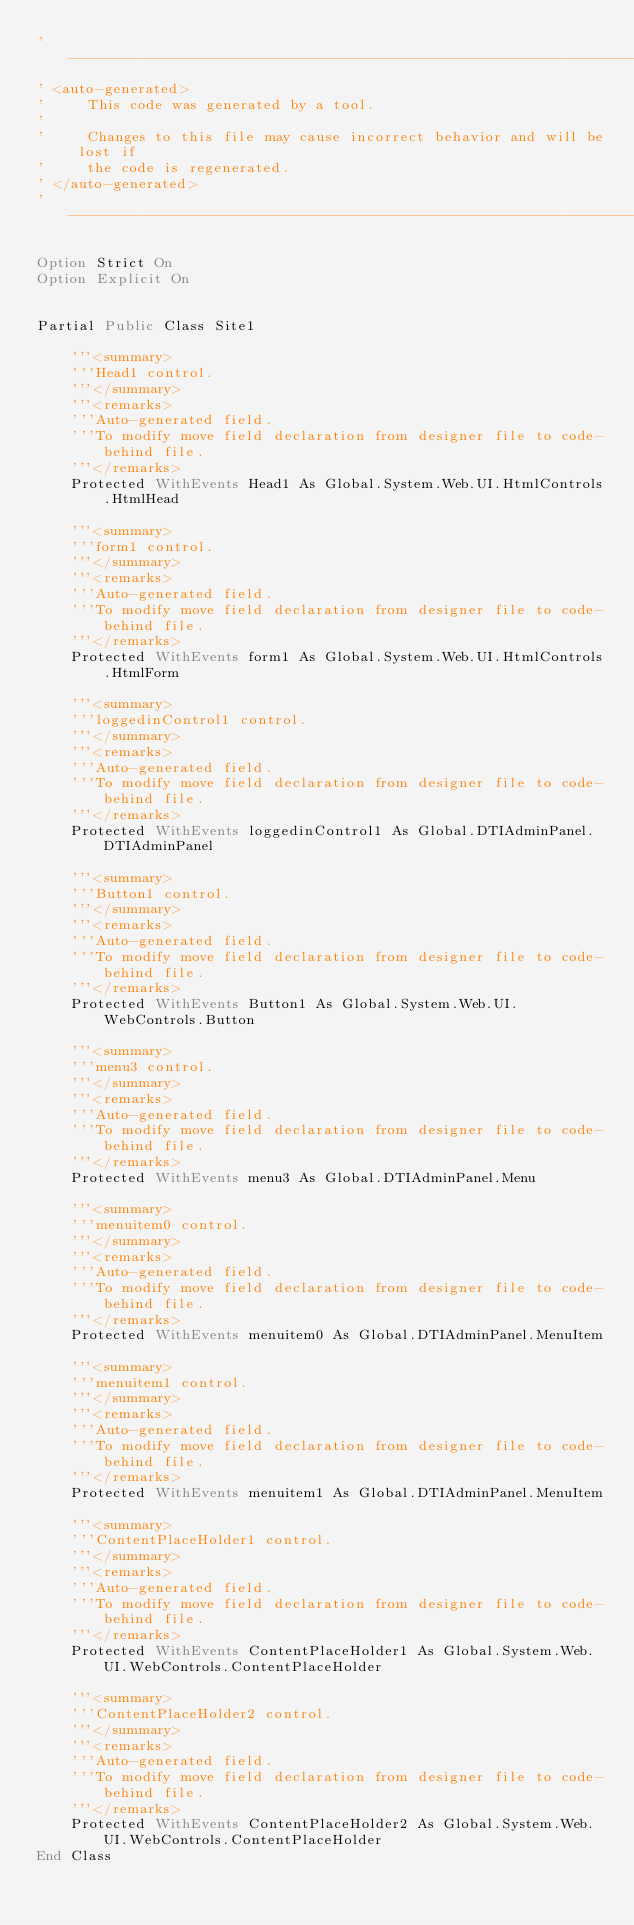<code> <loc_0><loc_0><loc_500><loc_500><_VisualBasic_>'------------------------------------------------------------------------------
' <auto-generated>
'     This code was generated by a tool.
'
'     Changes to this file may cause incorrect behavior and will be lost if
'     the code is regenerated. 
' </auto-generated>
'------------------------------------------------------------------------------

Option Strict On
Option Explicit On


Partial Public Class Site1

    '''<summary>
    '''Head1 control.
    '''</summary>
    '''<remarks>
    '''Auto-generated field.
    '''To modify move field declaration from designer file to code-behind file.
    '''</remarks>
    Protected WithEvents Head1 As Global.System.Web.UI.HtmlControls.HtmlHead

    '''<summary>
    '''form1 control.
    '''</summary>
    '''<remarks>
    '''Auto-generated field.
    '''To modify move field declaration from designer file to code-behind file.
    '''</remarks>
    Protected WithEvents form1 As Global.System.Web.UI.HtmlControls.HtmlForm

    '''<summary>
    '''loggedinControl1 control.
    '''</summary>
    '''<remarks>
    '''Auto-generated field.
    '''To modify move field declaration from designer file to code-behind file.
    '''</remarks>
    Protected WithEvents loggedinControl1 As Global.DTIAdminPanel.DTIAdminPanel

    '''<summary>
    '''Button1 control.
    '''</summary>
    '''<remarks>
    '''Auto-generated field.
    '''To modify move field declaration from designer file to code-behind file.
    '''</remarks>
    Protected WithEvents Button1 As Global.System.Web.UI.WebControls.Button

    '''<summary>
    '''menu3 control.
    '''</summary>
    '''<remarks>
    '''Auto-generated field.
    '''To modify move field declaration from designer file to code-behind file.
    '''</remarks>
    Protected WithEvents menu3 As Global.DTIAdminPanel.Menu

    '''<summary>
    '''menuitem0 control.
    '''</summary>
    '''<remarks>
    '''Auto-generated field.
    '''To modify move field declaration from designer file to code-behind file.
    '''</remarks>
    Protected WithEvents menuitem0 As Global.DTIAdminPanel.MenuItem

    '''<summary>
    '''menuitem1 control.
    '''</summary>
    '''<remarks>
    '''Auto-generated field.
    '''To modify move field declaration from designer file to code-behind file.
    '''</remarks>
    Protected WithEvents menuitem1 As Global.DTIAdminPanel.MenuItem

    '''<summary>
    '''ContentPlaceHolder1 control.
    '''</summary>
    '''<remarks>
    '''Auto-generated field.
    '''To modify move field declaration from designer file to code-behind file.
    '''</remarks>
    Protected WithEvents ContentPlaceHolder1 As Global.System.Web.UI.WebControls.ContentPlaceHolder

    '''<summary>
    '''ContentPlaceHolder2 control.
    '''</summary>
    '''<remarks>
    '''Auto-generated field.
    '''To modify move field declaration from designer file to code-behind file.
    '''</remarks>
    Protected WithEvents ContentPlaceHolder2 As Global.System.Web.UI.WebControls.ContentPlaceHolder
End Class
</code> 